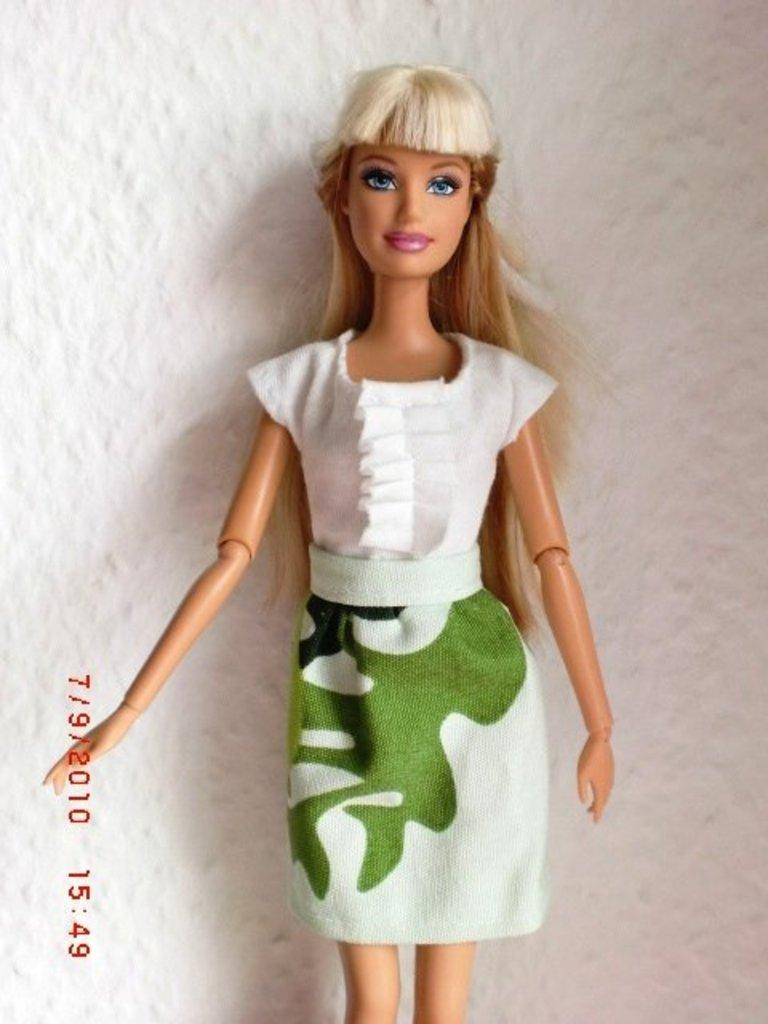What can be seen in the background of the image? There is a wall in the background of the image. What is the main subject in the middle of the image? There is a doll in the middle of the image. What is the doll wearing? The doll is wearing a white and green colored dress. What type of sign is the doll holding in the image? There is no sign present in the image; the doll is not holding anything. 